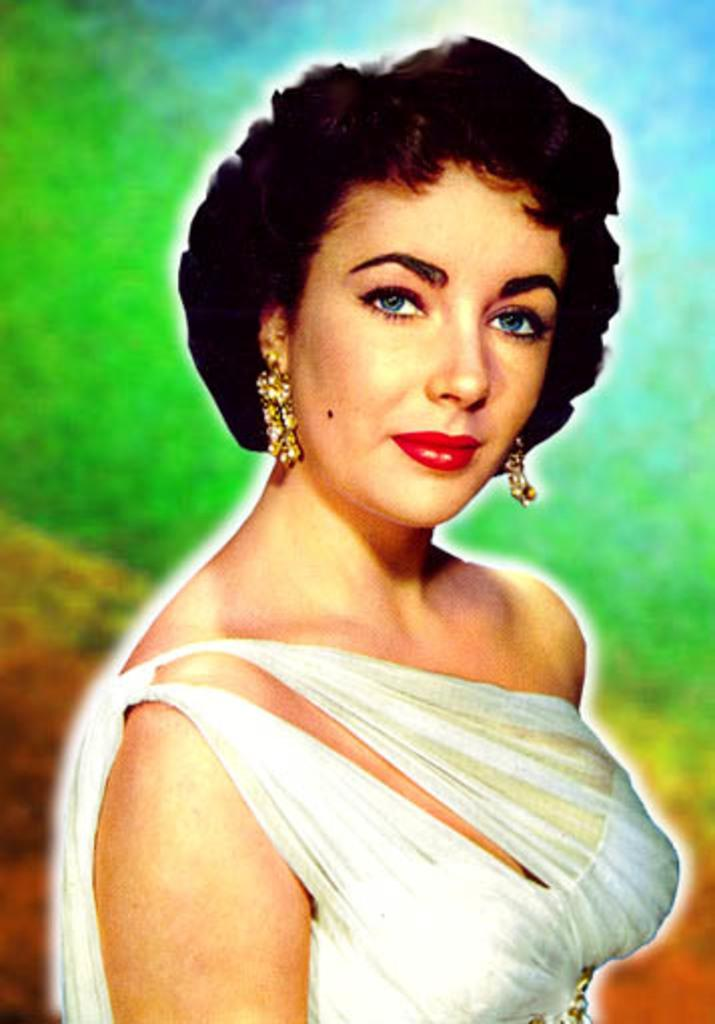Who is the main subject in the image? There is a woman in the image. Where is the woman positioned in the image? The woman is standing in the center of the image. What is the woman wearing in the image? The woman is wearing a white dress. What emotion is the woman expressing in the image? The woman is smiling, as seen on her face. What time is displayed on the clock in the image? There is no clock present in the image. How many cars can be seen in the image? There are no cars present in the image. 